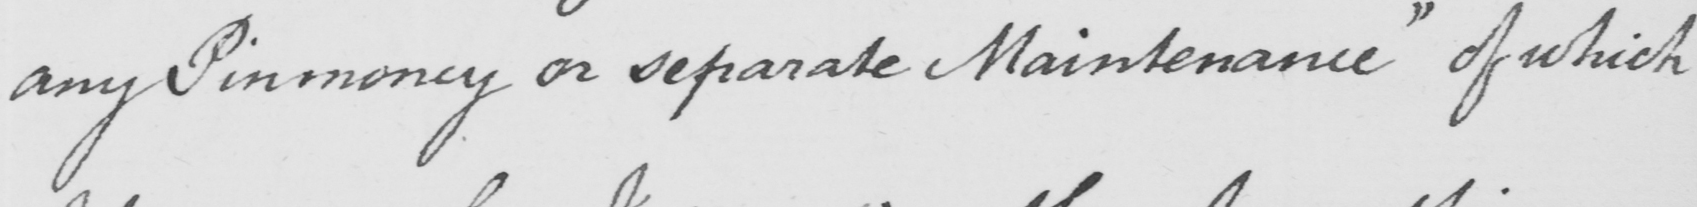Please transcribe the handwritten text in this image. any Pinmoney or separate Maintenance" of which 